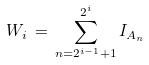Convert formula to latex. <formula><loc_0><loc_0><loc_500><loc_500>W _ { i } \, = \, \sum _ { n = 2 ^ { i - 1 } + 1 } ^ { 2 ^ { i } } I _ { A _ { n } }</formula> 